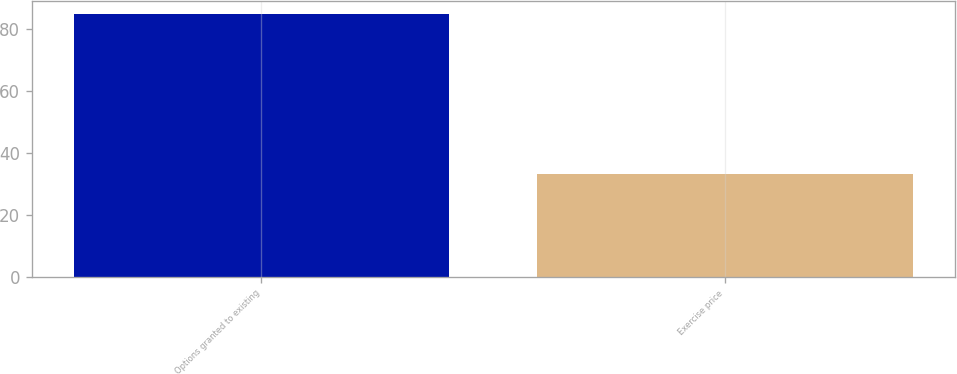<chart> <loc_0><loc_0><loc_500><loc_500><bar_chart><fcel>Options granted to existing<fcel>Exercise price<nl><fcel>85<fcel>33.23<nl></chart> 